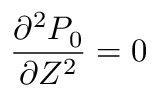<formula> <loc_0><loc_0><loc_500><loc_500>\frac { \partial ^ { 2 } P _ { 0 } } { \partial Z ^ { 2 } } = 0</formula> 